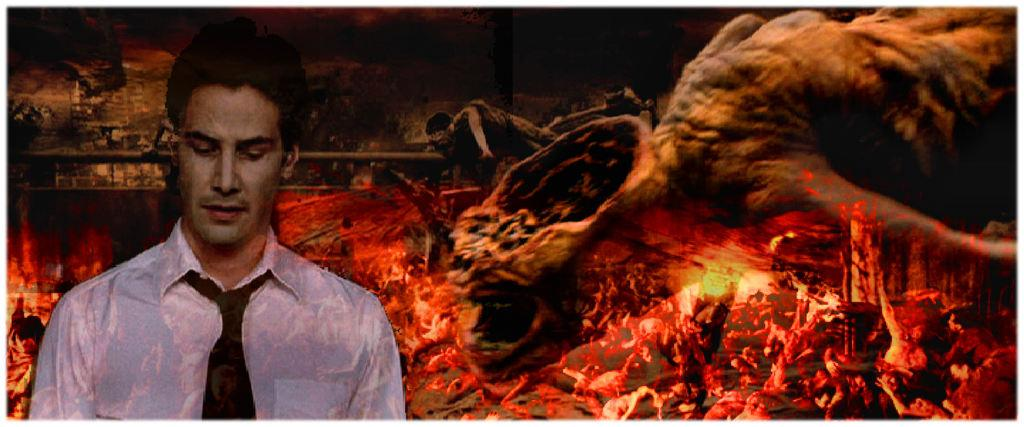What is the main subject of the image? There is a person in the image. What else can be seen in the image besides the person? There is fire in the image. How many grapes are being held by the cow in the image? There is no cow or grapes present in the image. What type of family can be seen in the image? There is no family depicted in the image; it features a person and fire. 